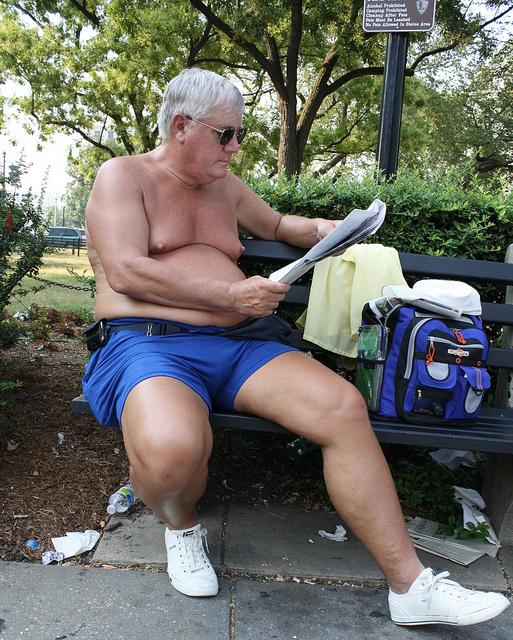What is the man sitting on?
Give a very brief answer. Bench. Is he wearing a shirt?
Short answer required. No. Does this man need a bra?
Short answer required. Yes. 